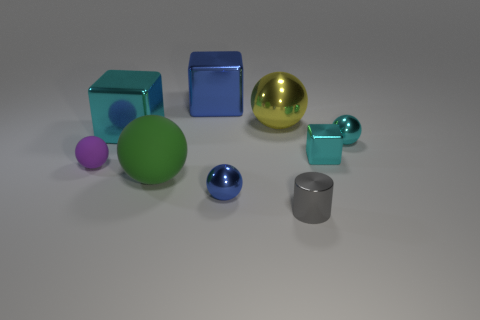Is there a tiny cube that has the same material as the cylinder?
Provide a short and direct response. Yes. What is the small sphere in front of the big matte sphere made of?
Your answer should be compact. Metal. There is a tiny shiny sphere to the left of the gray shiny cylinder; is it the same color as the tiny ball that is to the left of the large green rubber object?
Make the answer very short. No. What is the color of the metal cylinder that is the same size as the purple thing?
Your answer should be very brief. Gray. What number of other things are there of the same shape as the small purple object?
Your answer should be very brief. 4. There is a matte thing that is on the left side of the big green object; what size is it?
Your answer should be very brief. Small. There is a cyan metallic block left of the large yellow metallic object; what number of shiny balls are in front of it?
Give a very brief answer. 2. What number of other things are there of the same size as the metal cylinder?
Provide a short and direct response. 4. Is the small cube the same color as the big shiny sphere?
Your response must be concise. No. Is the shape of the large shiny object to the right of the blue block the same as  the large green rubber thing?
Provide a short and direct response. Yes. 